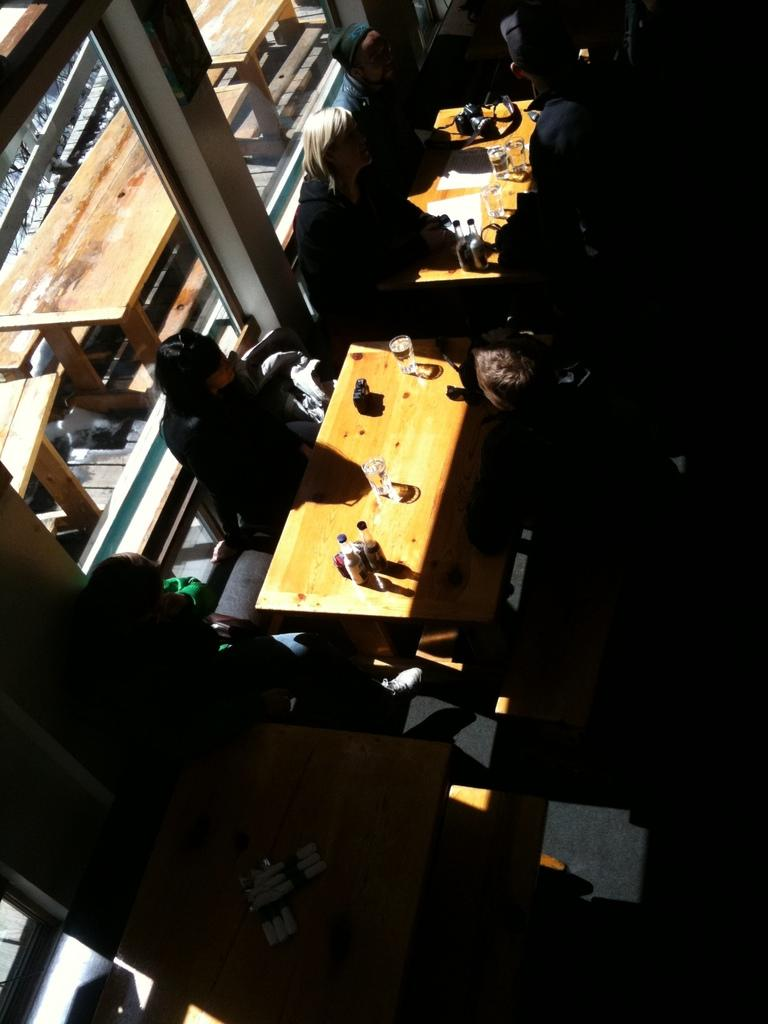Who or what can be seen in the image? There are people in the image. What is on the table in the image? There are objects on a table in the image. What feature allows natural light to enter the room in the image? There is a window in the image. What can be seen through the window in the image? There are tables visible behind the window. How many dogs are sitting on the table in the image? There are no dogs present in the image; it only features people and objects on the table. Can you see an ant crawling on the window in the image? There is no ant visible on the window in the image. 